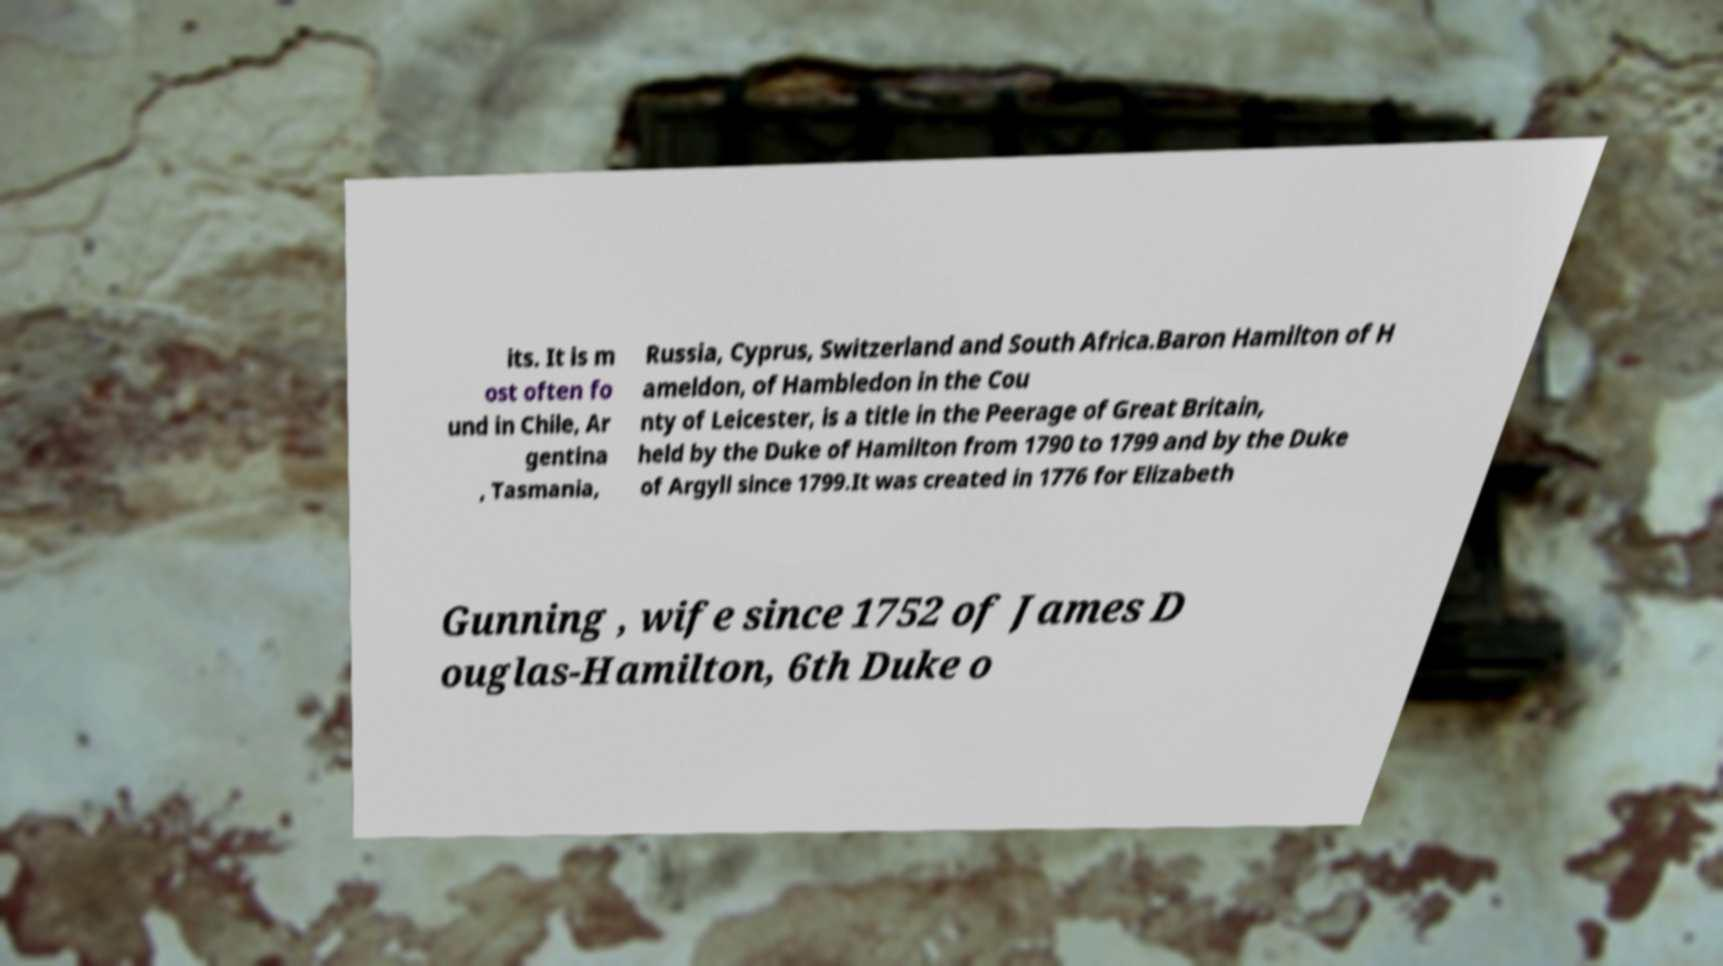Please read and relay the text visible in this image. What does it say? its. It is m ost often fo und in Chile, Ar gentina , Tasmania, Russia, Cyprus, Switzerland and South Africa.Baron Hamilton of H ameldon, of Hambledon in the Cou nty of Leicester, is a title in the Peerage of Great Britain, held by the Duke of Hamilton from 1790 to 1799 and by the Duke of Argyll since 1799.It was created in 1776 for Elizabeth Gunning , wife since 1752 of James D ouglas-Hamilton, 6th Duke o 